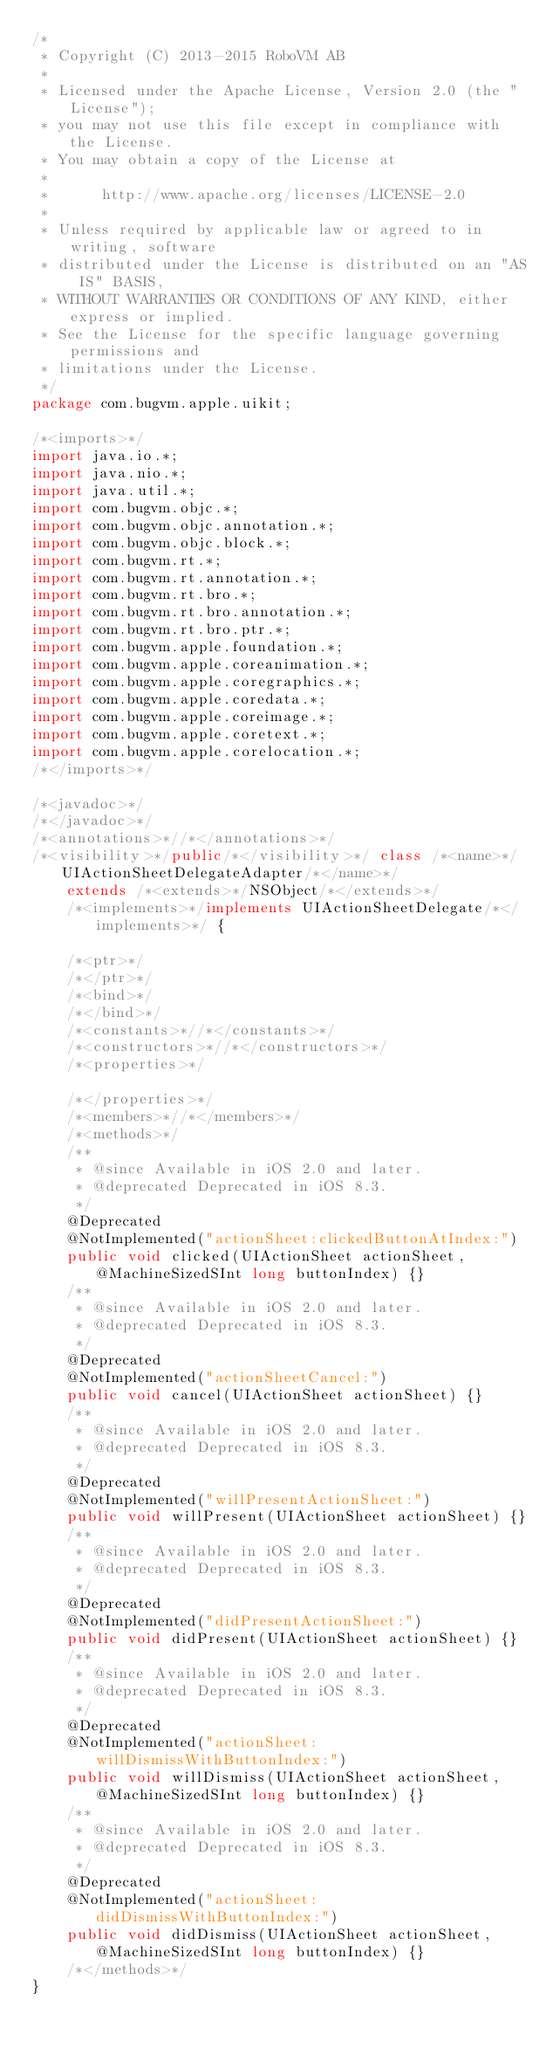Convert code to text. <code><loc_0><loc_0><loc_500><loc_500><_Java_>/*
 * Copyright (C) 2013-2015 RoboVM AB
 *
 * Licensed under the Apache License, Version 2.0 (the "License");
 * you may not use this file except in compliance with the License.
 * You may obtain a copy of the License at
 *
 *      http://www.apache.org/licenses/LICENSE-2.0
 *
 * Unless required by applicable law or agreed to in writing, software
 * distributed under the License is distributed on an "AS IS" BASIS,
 * WITHOUT WARRANTIES OR CONDITIONS OF ANY KIND, either express or implied.
 * See the License for the specific language governing permissions and
 * limitations under the License.
 */
package com.bugvm.apple.uikit;

/*<imports>*/
import java.io.*;
import java.nio.*;
import java.util.*;
import com.bugvm.objc.*;
import com.bugvm.objc.annotation.*;
import com.bugvm.objc.block.*;
import com.bugvm.rt.*;
import com.bugvm.rt.annotation.*;
import com.bugvm.rt.bro.*;
import com.bugvm.rt.bro.annotation.*;
import com.bugvm.rt.bro.ptr.*;
import com.bugvm.apple.foundation.*;
import com.bugvm.apple.coreanimation.*;
import com.bugvm.apple.coregraphics.*;
import com.bugvm.apple.coredata.*;
import com.bugvm.apple.coreimage.*;
import com.bugvm.apple.coretext.*;
import com.bugvm.apple.corelocation.*;
/*</imports>*/

/*<javadoc>*/
/*</javadoc>*/
/*<annotations>*//*</annotations>*/
/*<visibility>*/public/*</visibility>*/ class /*<name>*/UIActionSheetDelegateAdapter/*</name>*/ 
    extends /*<extends>*/NSObject/*</extends>*/ 
    /*<implements>*/implements UIActionSheetDelegate/*</implements>*/ {

    /*<ptr>*/
    /*</ptr>*/
    /*<bind>*/
    /*</bind>*/
    /*<constants>*//*</constants>*/
    /*<constructors>*//*</constructors>*/
    /*<properties>*/
    
    /*</properties>*/
    /*<members>*//*</members>*/
    /*<methods>*/
    /**
     * @since Available in iOS 2.0 and later.
     * @deprecated Deprecated in iOS 8.3.
     */
    @Deprecated
    @NotImplemented("actionSheet:clickedButtonAtIndex:")
    public void clicked(UIActionSheet actionSheet, @MachineSizedSInt long buttonIndex) {}
    /**
     * @since Available in iOS 2.0 and later.
     * @deprecated Deprecated in iOS 8.3.
     */
    @Deprecated
    @NotImplemented("actionSheetCancel:")
    public void cancel(UIActionSheet actionSheet) {}
    /**
     * @since Available in iOS 2.0 and later.
     * @deprecated Deprecated in iOS 8.3.
     */
    @Deprecated
    @NotImplemented("willPresentActionSheet:")
    public void willPresent(UIActionSheet actionSheet) {}
    /**
     * @since Available in iOS 2.0 and later.
     * @deprecated Deprecated in iOS 8.3.
     */
    @Deprecated
    @NotImplemented("didPresentActionSheet:")
    public void didPresent(UIActionSheet actionSheet) {}
    /**
     * @since Available in iOS 2.0 and later.
     * @deprecated Deprecated in iOS 8.3.
     */
    @Deprecated
    @NotImplemented("actionSheet:willDismissWithButtonIndex:")
    public void willDismiss(UIActionSheet actionSheet, @MachineSizedSInt long buttonIndex) {}
    /**
     * @since Available in iOS 2.0 and later.
     * @deprecated Deprecated in iOS 8.3.
     */
    @Deprecated
    @NotImplemented("actionSheet:didDismissWithButtonIndex:")
    public void didDismiss(UIActionSheet actionSheet, @MachineSizedSInt long buttonIndex) {}
    /*</methods>*/
}
</code> 